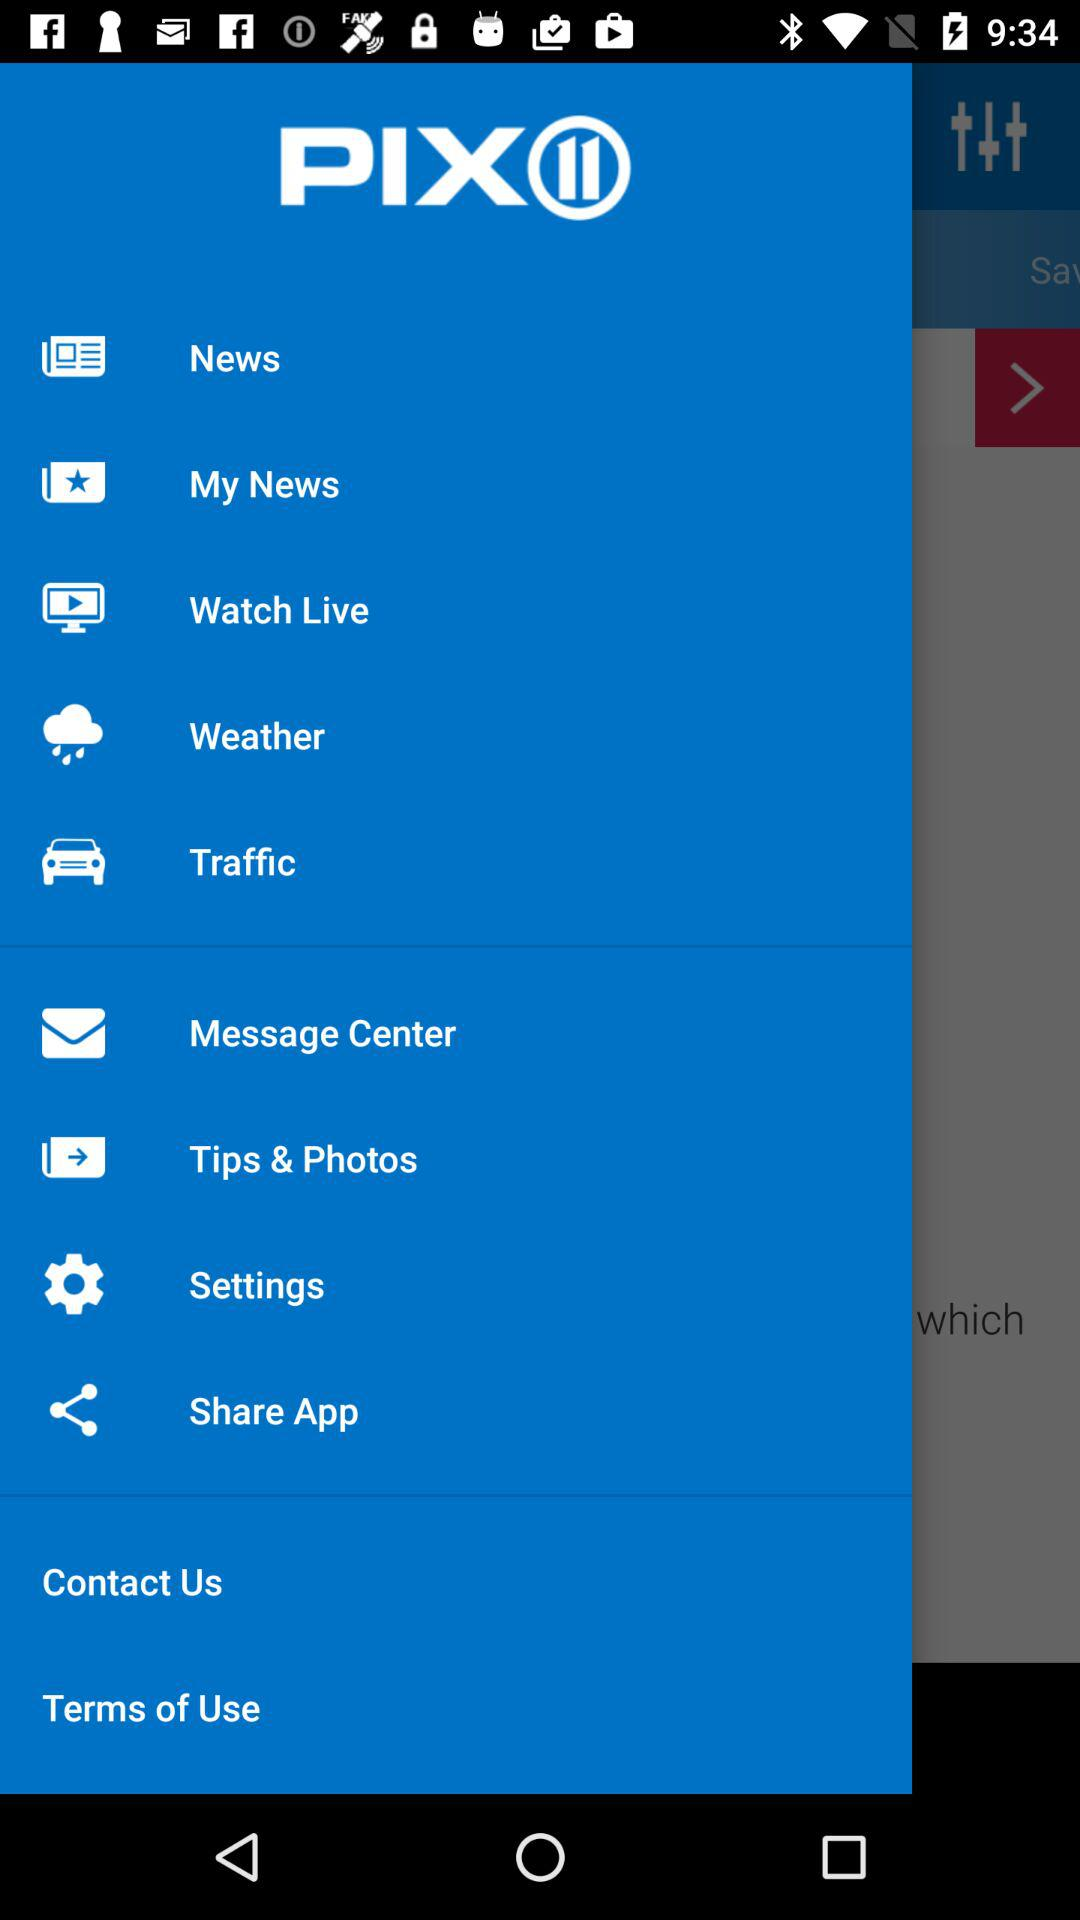What is the application name? The application name is "PIX". 